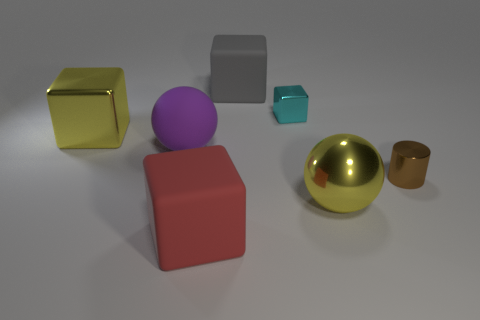There is a large purple rubber object; does it have the same shape as the big yellow shiny thing behind the cylinder? The large purple object in the image is spherical, similar to a ball, while the big yellow object behind the cylinder appears to be a cube with its distinct edges and flat faces. Therefore, they do not share the same shape. 